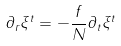Convert formula to latex. <formula><loc_0><loc_0><loc_500><loc_500>\partial _ { r } \xi ^ { t } = - \frac { f } { N } \partial _ { t } \xi ^ { t }</formula> 